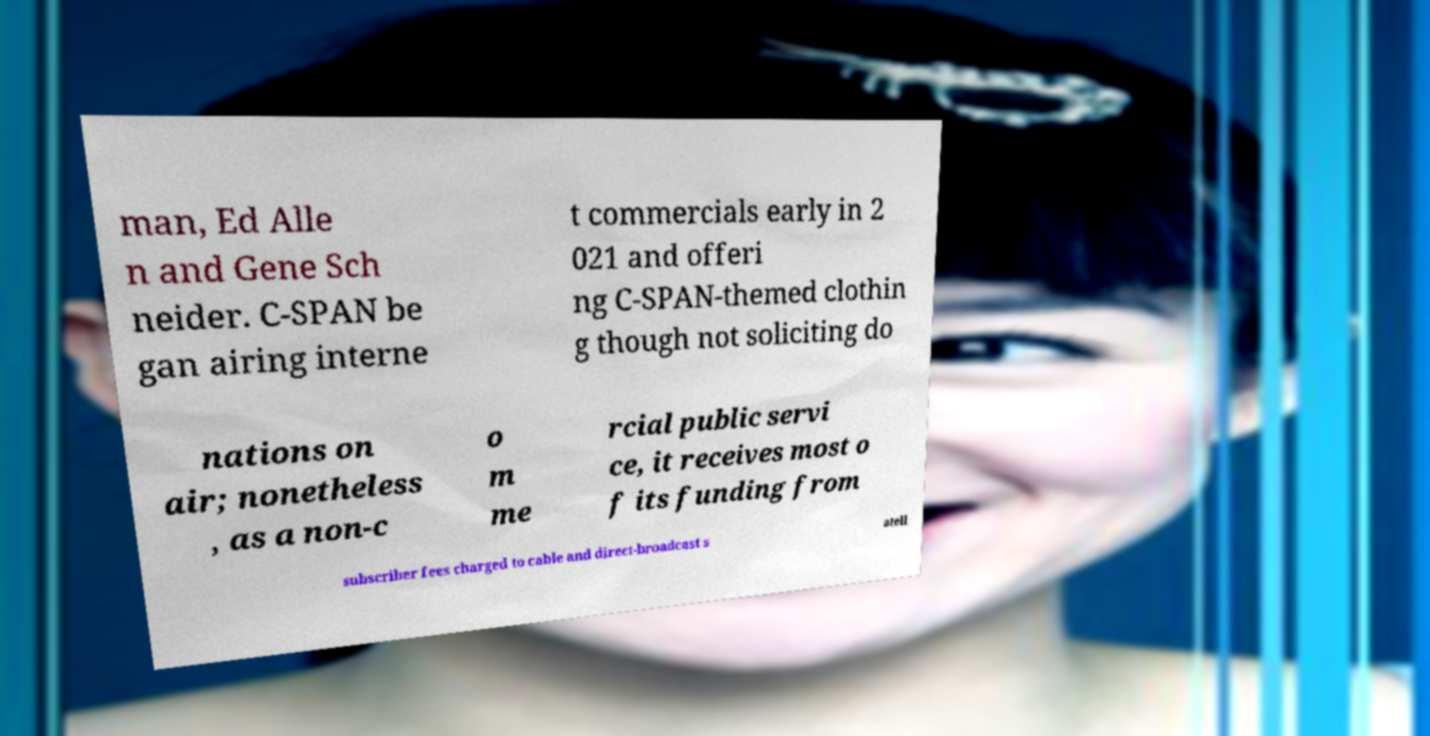What messages or text are displayed in this image? I need them in a readable, typed format. man, Ed Alle n and Gene Sch neider. C-SPAN be gan airing interne t commercials early in 2 021 and offeri ng C-SPAN-themed clothin g though not soliciting do nations on air; nonetheless , as a non-c o m me rcial public servi ce, it receives most o f its funding from subscriber fees charged to cable and direct-broadcast s atell 